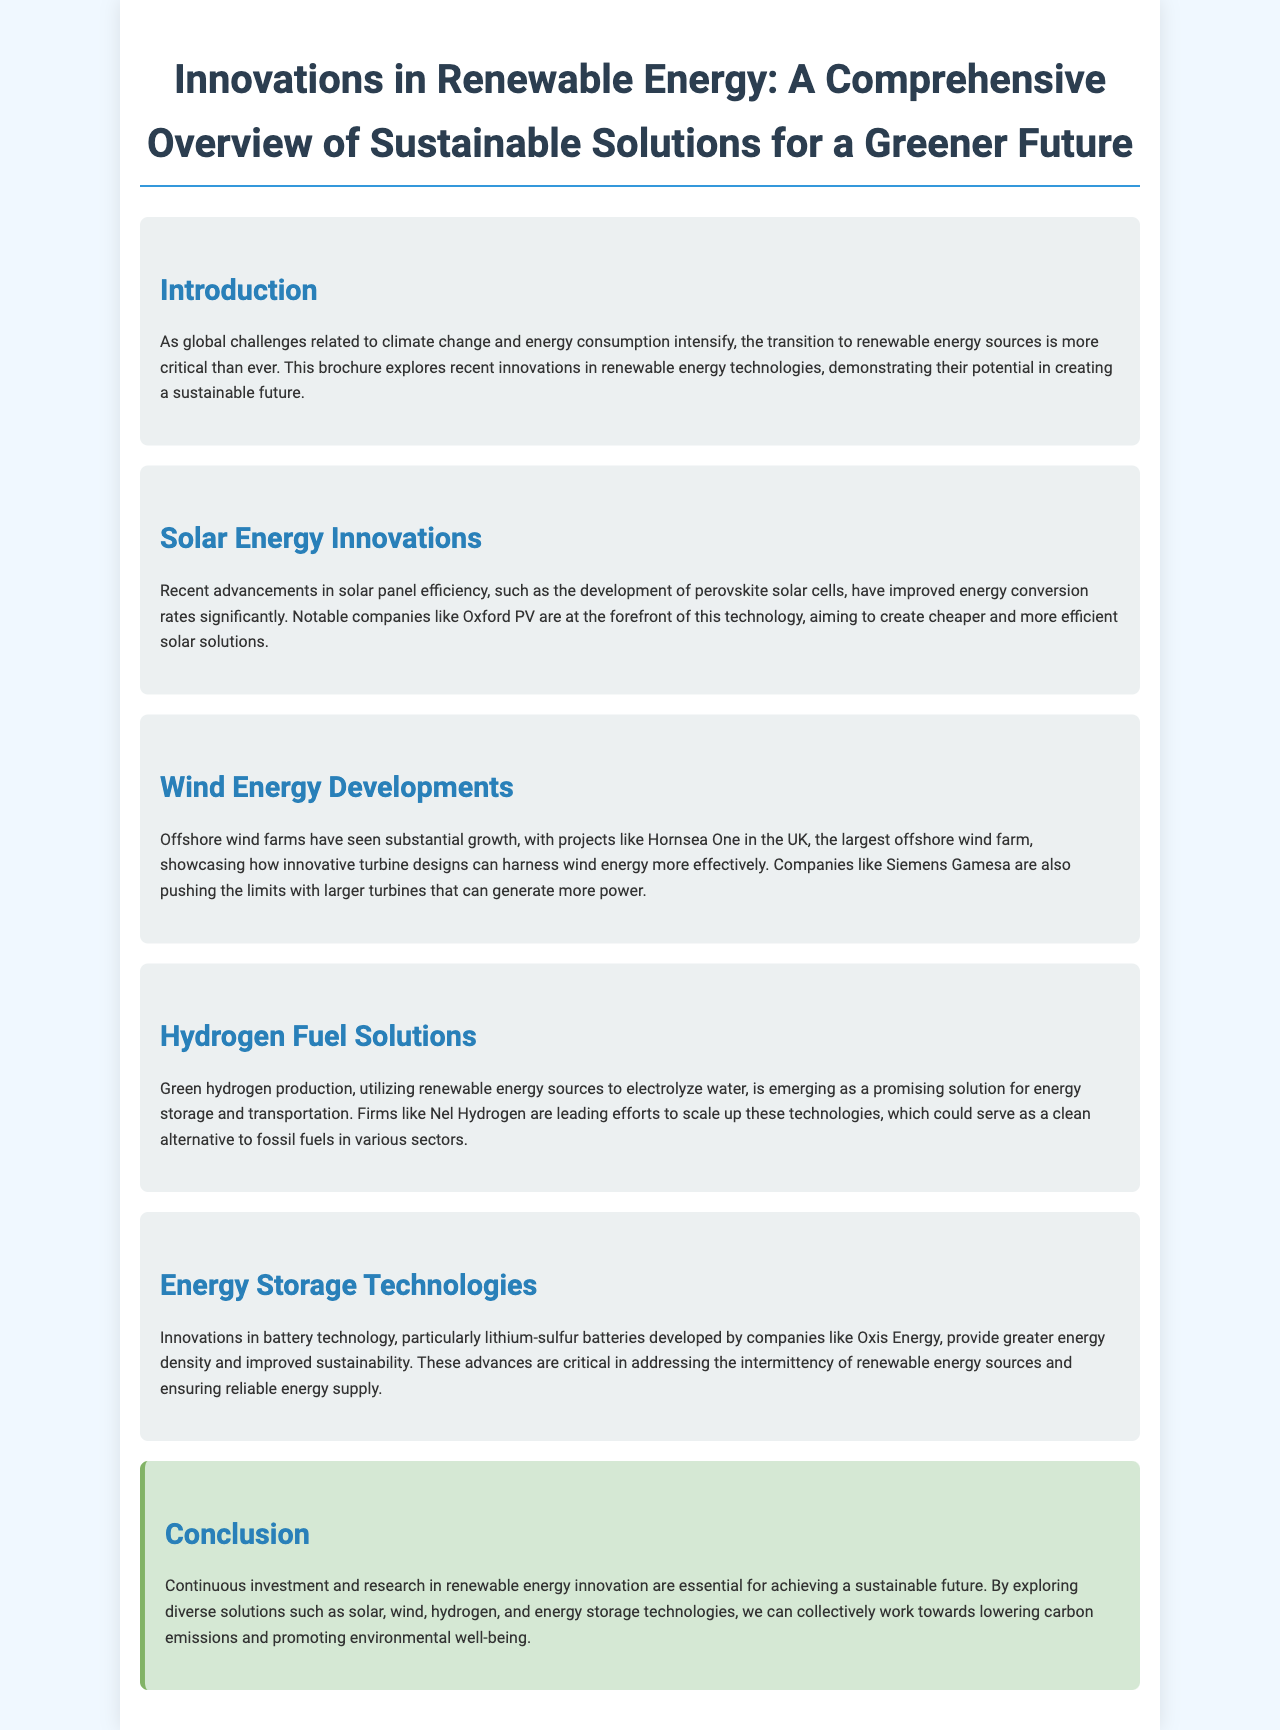What is the title of the brochure? The title of the brochure is prominently displayed at the top of the document, summarizing the key focus area.
Answer: Innovations in Renewable Energy: A Comprehensive Overview of Sustainable Solutions for a Greener Future Which company is known for developing perovskite solar cells? The brochure mentions Oxford PV specifically as a leader in the development of this technology.
Answer: Oxford PV What is the name of the largest offshore wind farm mentioned? The document highlights Hornsea One as the largest offshore wind farm.
Answer: Hornsea One What type of batteries is being developed by Oxis Energy? The document refers to lithium-sulfur batteries, emphasizing their significance in energy technology.
Answer: Lithium-sulfur batteries What renewable energy source is used to produce green hydrogen? The text states that green hydrogen is produced by electrolyzing water using renewable energy sources.
Answer: Renewable energy sources Why is investment in renewable energy innovation essential? The conclusion outlines that investment and research in renewable energy are crucial for sustainability and lowering carbon emissions.
Answer: To achieve a sustainable future 